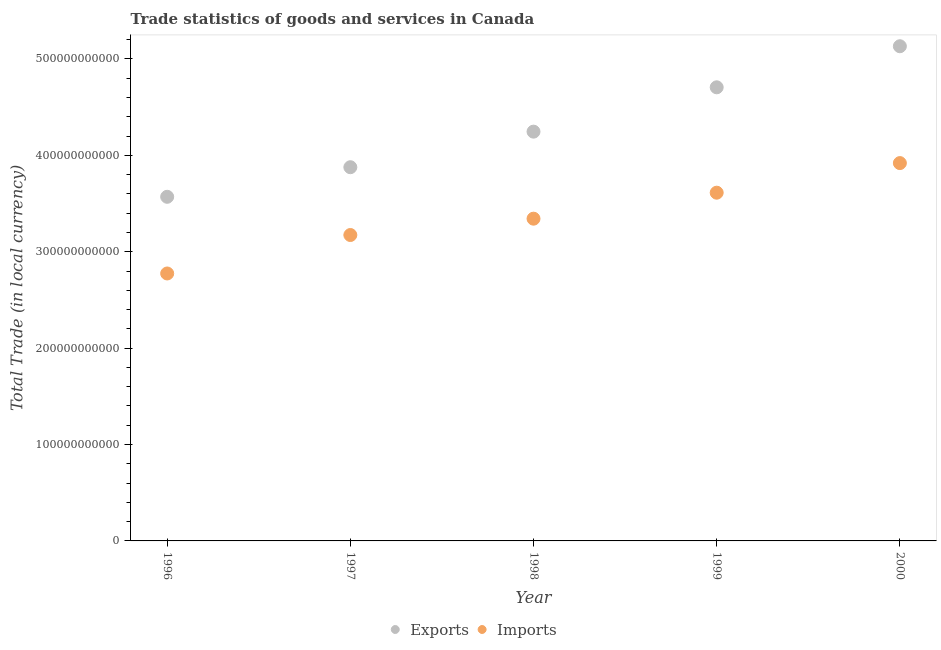How many different coloured dotlines are there?
Provide a short and direct response. 2. Is the number of dotlines equal to the number of legend labels?
Ensure brevity in your answer.  Yes. What is the imports of goods and services in 2000?
Provide a succinct answer. 3.92e+11. Across all years, what is the maximum imports of goods and services?
Make the answer very short. 3.92e+11. Across all years, what is the minimum imports of goods and services?
Your answer should be very brief. 2.77e+11. What is the total imports of goods and services in the graph?
Give a very brief answer. 1.68e+12. What is the difference between the imports of goods and services in 1998 and that in 1999?
Your response must be concise. -2.70e+1. What is the difference between the imports of goods and services in 1998 and the export of goods and services in 2000?
Your response must be concise. -1.79e+11. What is the average export of goods and services per year?
Your answer should be very brief. 4.31e+11. In the year 1998, what is the difference between the imports of goods and services and export of goods and services?
Make the answer very short. -9.03e+1. In how many years, is the export of goods and services greater than 80000000000 LCU?
Keep it short and to the point. 5. What is the ratio of the imports of goods and services in 1997 to that in 2000?
Your response must be concise. 0.81. Is the difference between the imports of goods and services in 1997 and 2000 greater than the difference between the export of goods and services in 1997 and 2000?
Your answer should be very brief. Yes. What is the difference between the highest and the second highest export of goods and services?
Offer a very short reply. 4.26e+1. What is the difference between the highest and the lowest export of goods and services?
Ensure brevity in your answer.  1.56e+11. Is the imports of goods and services strictly greater than the export of goods and services over the years?
Offer a terse response. No. How many dotlines are there?
Your response must be concise. 2. How many years are there in the graph?
Offer a very short reply. 5. What is the difference between two consecutive major ticks on the Y-axis?
Your answer should be very brief. 1.00e+11. Are the values on the major ticks of Y-axis written in scientific E-notation?
Ensure brevity in your answer.  No. Does the graph contain any zero values?
Your answer should be very brief. No. How many legend labels are there?
Provide a succinct answer. 2. How are the legend labels stacked?
Keep it short and to the point. Horizontal. What is the title of the graph?
Keep it short and to the point. Trade statistics of goods and services in Canada. Does "Frequency of shipment arrival" appear as one of the legend labels in the graph?
Your response must be concise. No. What is the label or title of the X-axis?
Offer a very short reply. Year. What is the label or title of the Y-axis?
Your answer should be compact. Total Trade (in local currency). What is the Total Trade (in local currency) of Exports in 1996?
Your response must be concise. 3.57e+11. What is the Total Trade (in local currency) in Imports in 1996?
Ensure brevity in your answer.  2.77e+11. What is the Total Trade (in local currency) of Exports in 1997?
Give a very brief answer. 3.88e+11. What is the Total Trade (in local currency) of Imports in 1997?
Your answer should be compact. 3.17e+11. What is the Total Trade (in local currency) in Exports in 1998?
Your response must be concise. 4.25e+11. What is the Total Trade (in local currency) in Imports in 1998?
Ensure brevity in your answer.  3.34e+11. What is the Total Trade (in local currency) in Exports in 1999?
Your answer should be compact. 4.71e+11. What is the Total Trade (in local currency) in Imports in 1999?
Provide a succinct answer. 3.61e+11. What is the Total Trade (in local currency) in Exports in 2000?
Your answer should be compact. 5.13e+11. What is the Total Trade (in local currency) in Imports in 2000?
Provide a short and direct response. 3.92e+11. Across all years, what is the maximum Total Trade (in local currency) in Exports?
Your answer should be very brief. 5.13e+11. Across all years, what is the maximum Total Trade (in local currency) of Imports?
Offer a very short reply. 3.92e+11. Across all years, what is the minimum Total Trade (in local currency) in Exports?
Your answer should be very brief. 3.57e+11. Across all years, what is the minimum Total Trade (in local currency) of Imports?
Make the answer very short. 2.77e+11. What is the total Total Trade (in local currency) of Exports in the graph?
Your answer should be very brief. 2.15e+12. What is the total Total Trade (in local currency) of Imports in the graph?
Ensure brevity in your answer.  1.68e+12. What is the difference between the Total Trade (in local currency) in Exports in 1996 and that in 1997?
Your answer should be compact. -3.07e+1. What is the difference between the Total Trade (in local currency) of Imports in 1996 and that in 1997?
Your answer should be compact. -3.99e+1. What is the difference between the Total Trade (in local currency) in Exports in 1996 and that in 1998?
Provide a short and direct response. -6.76e+1. What is the difference between the Total Trade (in local currency) of Imports in 1996 and that in 1998?
Your answer should be compact. -5.69e+1. What is the difference between the Total Trade (in local currency) in Exports in 1996 and that in 1999?
Provide a succinct answer. -1.14e+11. What is the difference between the Total Trade (in local currency) in Imports in 1996 and that in 1999?
Your answer should be compact. -8.38e+1. What is the difference between the Total Trade (in local currency) in Exports in 1996 and that in 2000?
Your response must be concise. -1.56e+11. What is the difference between the Total Trade (in local currency) in Imports in 1996 and that in 2000?
Offer a very short reply. -1.15e+11. What is the difference between the Total Trade (in local currency) in Exports in 1997 and that in 1998?
Your answer should be very brief. -3.69e+1. What is the difference between the Total Trade (in local currency) in Imports in 1997 and that in 1998?
Offer a very short reply. -1.69e+1. What is the difference between the Total Trade (in local currency) in Exports in 1997 and that in 1999?
Provide a short and direct response. -8.29e+1. What is the difference between the Total Trade (in local currency) in Imports in 1997 and that in 1999?
Provide a succinct answer. -4.39e+1. What is the difference between the Total Trade (in local currency) of Exports in 1997 and that in 2000?
Ensure brevity in your answer.  -1.26e+11. What is the difference between the Total Trade (in local currency) of Imports in 1997 and that in 2000?
Make the answer very short. -7.46e+1. What is the difference between the Total Trade (in local currency) in Exports in 1998 and that in 1999?
Offer a terse response. -4.60e+1. What is the difference between the Total Trade (in local currency) of Imports in 1998 and that in 1999?
Provide a succinct answer. -2.70e+1. What is the difference between the Total Trade (in local currency) of Exports in 1998 and that in 2000?
Your response must be concise. -8.86e+1. What is the difference between the Total Trade (in local currency) in Imports in 1998 and that in 2000?
Make the answer very short. -5.77e+1. What is the difference between the Total Trade (in local currency) in Exports in 1999 and that in 2000?
Your response must be concise. -4.26e+1. What is the difference between the Total Trade (in local currency) of Imports in 1999 and that in 2000?
Offer a terse response. -3.07e+1. What is the difference between the Total Trade (in local currency) of Exports in 1996 and the Total Trade (in local currency) of Imports in 1997?
Give a very brief answer. 3.97e+1. What is the difference between the Total Trade (in local currency) of Exports in 1996 and the Total Trade (in local currency) of Imports in 1998?
Offer a very short reply. 2.27e+1. What is the difference between the Total Trade (in local currency) in Exports in 1996 and the Total Trade (in local currency) in Imports in 1999?
Make the answer very short. -4.26e+09. What is the difference between the Total Trade (in local currency) in Exports in 1996 and the Total Trade (in local currency) in Imports in 2000?
Offer a terse response. -3.50e+1. What is the difference between the Total Trade (in local currency) in Exports in 1997 and the Total Trade (in local currency) in Imports in 1998?
Offer a terse response. 5.34e+1. What is the difference between the Total Trade (in local currency) of Exports in 1997 and the Total Trade (in local currency) of Imports in 1999?
Offer a terse response. 2.64e+1. What is the difference between the Total Trade (in local currency) of Exports in 1997 and the Total Trade (in local currency) of Imports in 2000?
Offer a terse response. -4.27e+09. What is the difference between the Total Trade (in local currency) of Exports in 1998 and the Total Trade (in local currency) of Imports in 1999?
Provide a succinct answer. 6.33e+1. What is the difference between the Total Trade (in local currency) in Exports in 1998 and the Total Trade (in local currency) in Imports in 2000?
Give a very brief answer. 3.26e+1. What is the difference between the Total Trade (in local currency) of Exports in 1999 and the Total Trade (in local currency) of Imports in 2000?
Your answer should be compact. 7.86e+1. What is the average Total Trade (in local currency) of Exports per year?
Your answer should be compact. 4.31e+11. What is the average Total Trade (in local currency) of Imports per year?
Offer a very short reply. 3.36e+11. In the year 1996, what is the difference between the Total Trade (in local currency) of Exports and Total Trade (in local currency) of Imports?
Your answer should be compact. 7.96e+1. In the year 1997, what is the difference between the Total Trade (in local currency) in Exports and Total Trade (in local currency) in Imports?
Ensure brevity in your answer.  7.03e+1. In the year 1998, what is the difference between the Total Trade (in local currency) in Exports and Total Trade (in local currency) in Imports?
Your answer should be compact. 9.03e+1. In the year 1999, what is the difference between the Total Trade (in local currency) in Exports and Total Trade (in local currency) in Imports?
Keep it short and to the point. 1.09e+11. In the year 2000, what is the difference between the Total Trade (in local currency) of Exports and Total Trade (in local currency) of Imports?
Your answer should be compact. 1.21e+11. What is the ratio of the Total Trade (in local currency) in Exports in 1996 to that in 1997?
Ensure brevity in your answer.  0.92. What is the ratio of the Total Trade (in local currency) of Imports in 1996 to that in 1997?
Keep it short and to the point. 0.87. What is the ratio of the Total Trade (in local currency) of Exports in 1996 to that in 1998?
Your answer should be very brief. 0.84. What is the ratio of the Total Trade (in local currency) in Imports in 1996 to that in 1998?
Ensure brevity in your answer.  0.83. What is the ratio of the Total Trade (in local currency) in Exports in 1996 to that in 1999?
Provide a succinct answer. 0.76. What is the ratio of the Total Trade (in local currency) in Imports in 1996 to that in 1999?
Offer a very short reply. 0.77. What is the ratio of the Total Trade (in local currency) of Exports in 1996 to that in 2000?
Give a very brief answer. 0.7. What is the ratio of the Total Trade (in local currency) in Imports in 1996 to that in 2000?
Keep it short and to the point. 0.71. What is the ratio of the Total Trade (in local currency) in Exports in 1997 to that in 1998?
Your answer should be very brief. 0.91. What is the ratio of the Total Trade (in local currency) in Imports in 1997 to that in 1998?
Offer a very short reply. 0.95. What is the ratio of the Total Trade (in local currency) of Exports in 1997 to that in 1999?
Provide a succinct answer. 0.82. What is the ratio of the Total Trade (in local currency) in Imports in 1997 to that in 1999?
Your answer should be compact. 0.88. What is the ratio of the Total Trade (in local currency) in Exports in 1997 to that in 2000?
Offer a terse response. 0.76. What is the ratio of the Total Trade (in local currency) of Imports in 1997 to that in 2000?
Offer a terse response. 0.81. What is the ratio of the Total Trade (in local currency) of Exports in 1998 to that in 1999?
Offer a terse response. 0.9. What is the ratio of the Total Trade (in local currency) of Imports in 1998 to that in 1999?
Keep it short and to the point. 0.93. What is the ratio of the Total Trade (in local currency) of Exports in 1998 to that in 2000?
Offer a very short reply. 0.83. What is the ratio of the Total Trade (in local currency) in Imports in 1998 to that in 2000?
Make the answer very short. 0.85. What is the ratio of the Total Trade (in local currency) of Exports in 1999 to that in 2000?
Your response must be concise. 0.92. What is the ratio of the Total Trade (in local currency) in Imports in 1999 to that in 2000?
Give a very brief answer. 0.92. What is the difference between the highest and the second highest Total Trade (in local currency) in Exports?
Your answer should be compact. 4.26e+1. What is the difference between the highest and the second highest Total Trade (in local currency) in Imports?
Provide a short and direct response. 3.07e+1. What is the difference between the highest and the lowest Total Trade (in local currency) in Exports?
Provide a short and direct response. 1.56e+11. What is the difference between the highest and the lowest Total Trade (in local currency) of Imports?
Provide a short and direct response. 1.15e+11. 